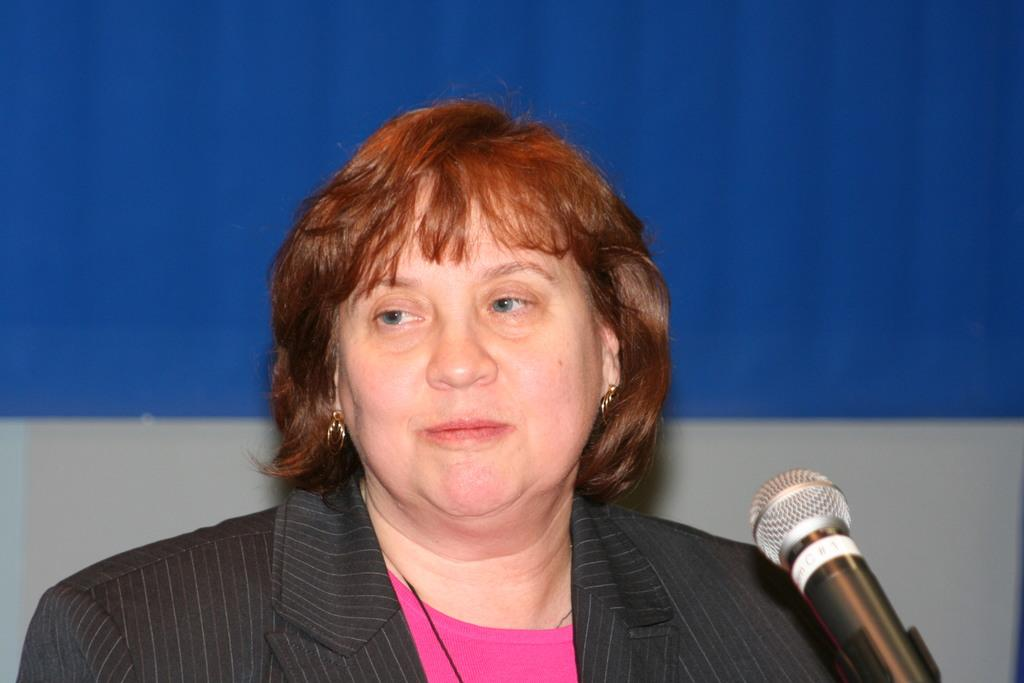What is the person in the image wearing? The person is wearing a black and grey color dress in the image. What object is in front of the person? There is a microphone (mic) in front of the person. How would you describe the background of the image? The background of the image is blue and ash in color. What type of yoke is being used by the person in the image? There is no yoke present in the image; the person is holding a microphone. How does the jelly contribute to the scene in the image? There is no jelly present in the image; it is not a part of the scene. 